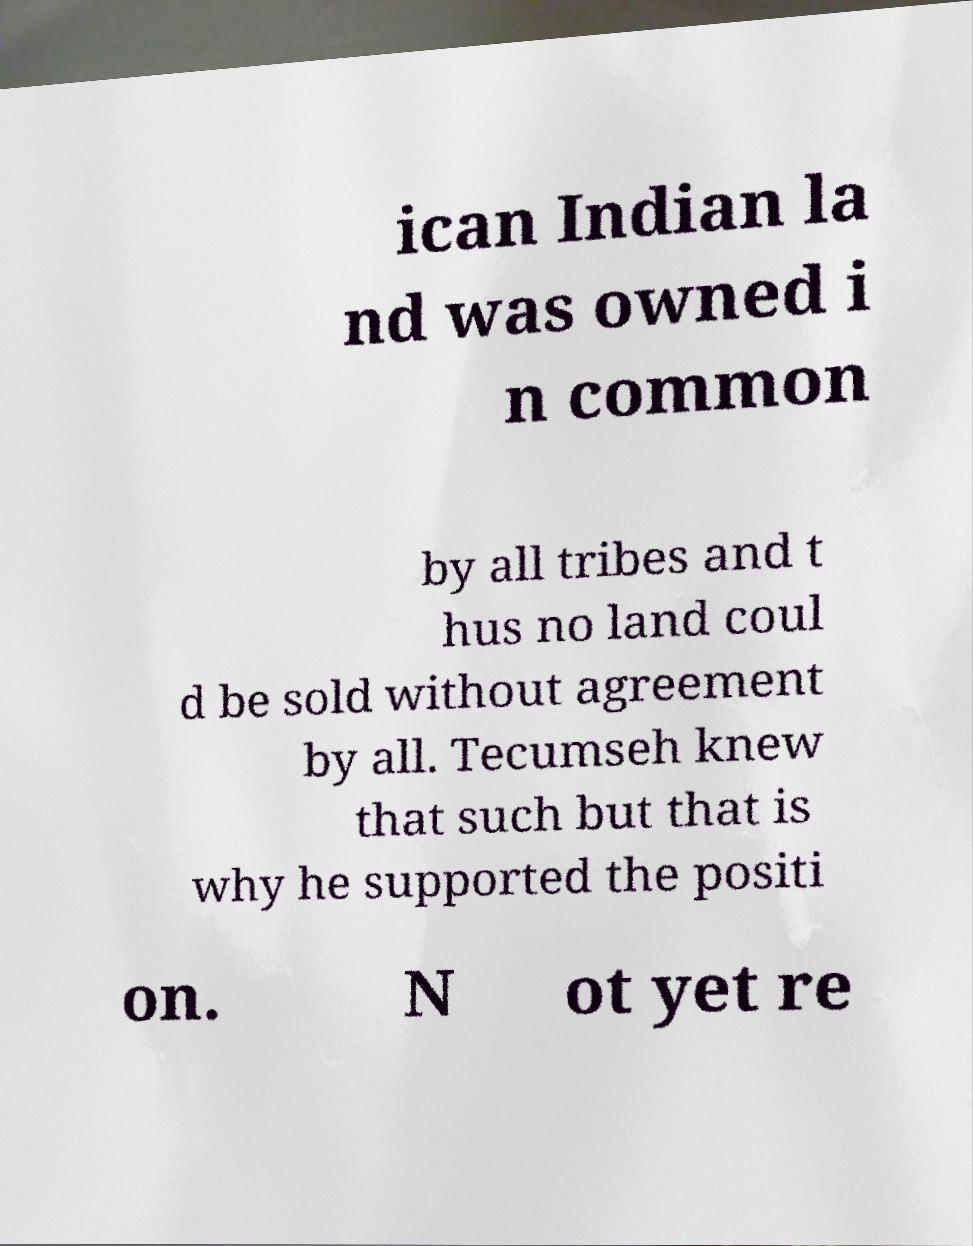Can you read and provide the text displayed in the image?This photo seems to have some interesting text. Can you extract and type it out for me? ican Indian la nd was owned i n common by all tribes and t hus no land coul d be sold without agreement by all. Tecumseh knew that such but that is why he supported the positi on. N ot yet re 